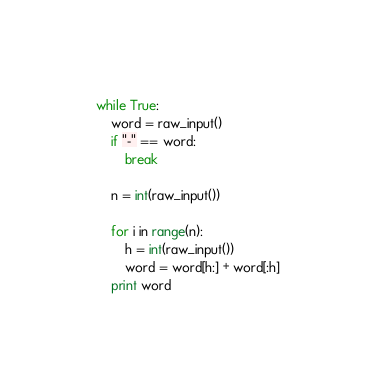<code> <loc_0><loc_0><loc_500><loc_500><_Python_>while True:
    word = raw_input()
    if "-" == word:
        break
 
    n = int(raw_input())

    for i in range(n):
        h = int(raw_input())
        word = word[h:] + word[:h]
    print word</code> 